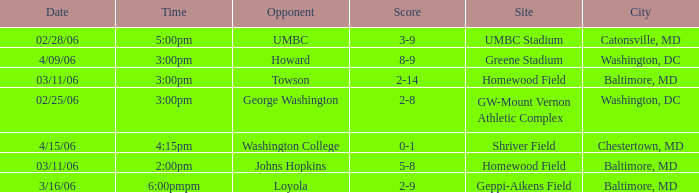What is the Date if the Site is Shriver Field? 4/15/06. 